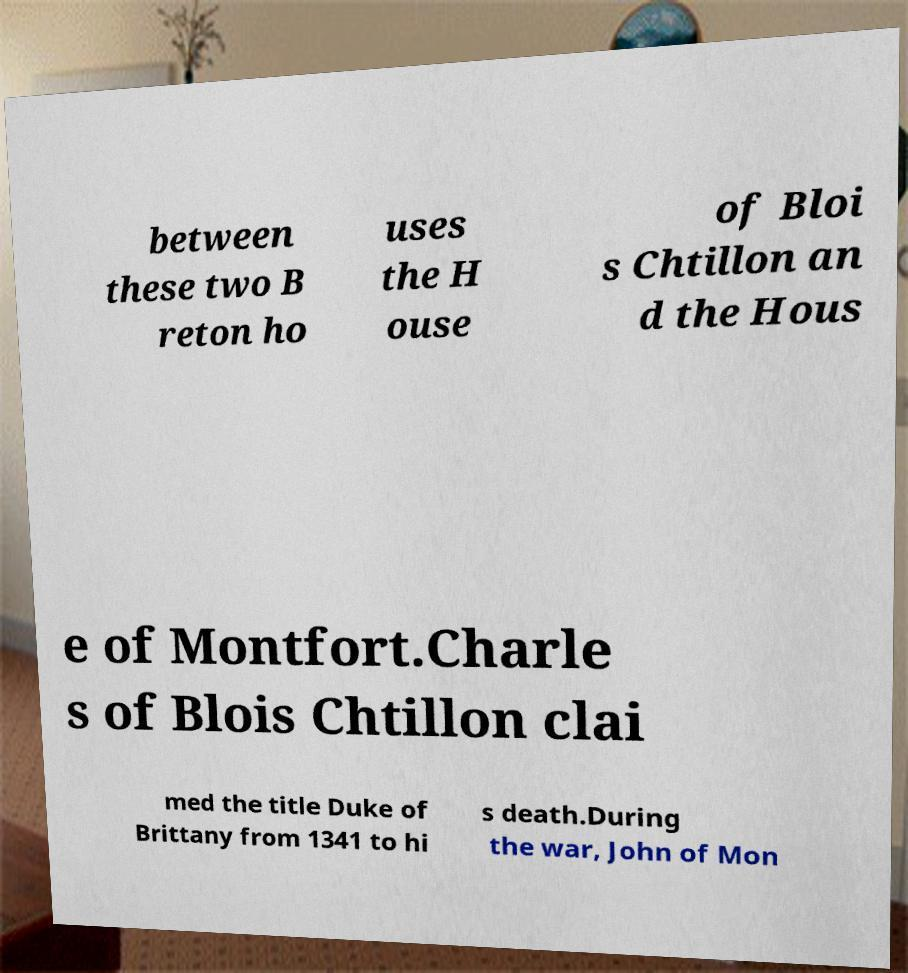Please read and relay the text visible in this image. What does it say? between these two B reton ho uses the H ouse of Bloi s Chtillon an d the Hous e of Montfort.Charle s of Blois Chtillon clai med the title Duke of Brittany from 1341 to hi s death.During the war, John of Mon 